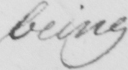Can you read and transcribe this handwriting? being 